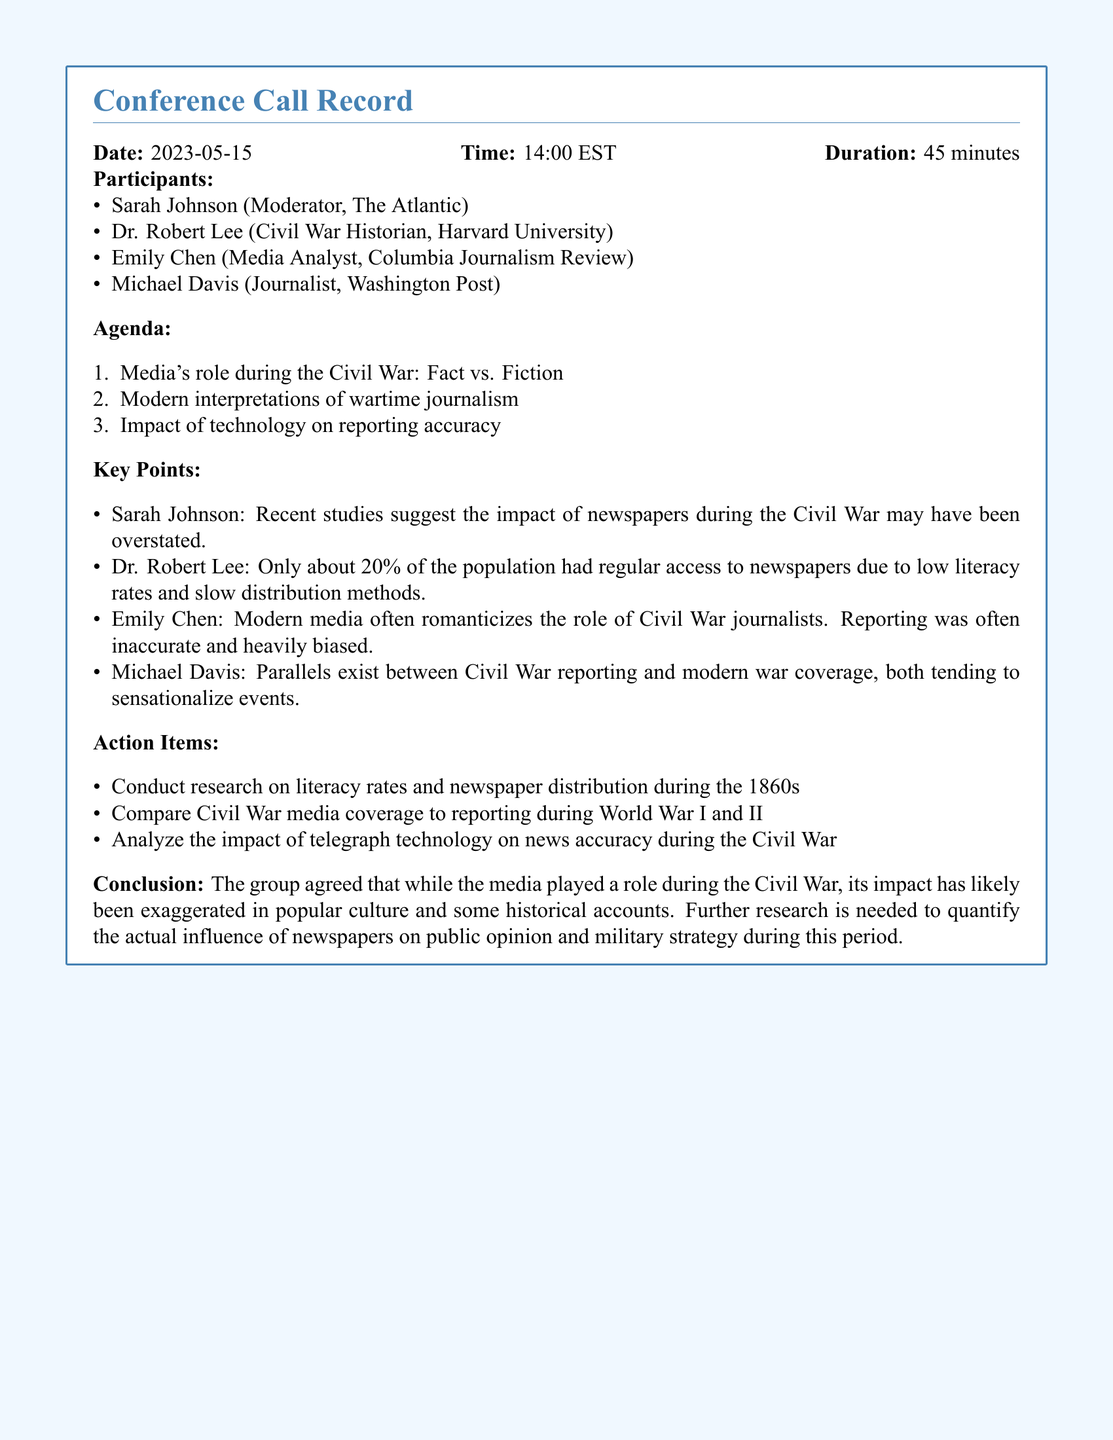what is the date of the conference call? The date of the conference call is stated at the beginning of the document.
Answer: 2023-05-15 who moderated the conference call? The document lists Sarah Johnson as the moderator of the conference call.
Answer: Sarah Johnson how long did the conference call last? The duration of the conference call is mentioned in the document.
Answer: 45 minutes what percentage of the population had regular access to newspapers during the Civil War? Dr. Robert Lee mentioned a specific percentage regarding newspaper access.
Answer: 20% which media organization's representative is named Michael Davis? The document specifies the media organization associated with Michael Davis.
Answer: Washington Post what was one of the key agenda items discussed? The document lists agenda items, including the media's role during the Civil War.
Answer: Media's role during the Civil War: Fact vs. Fiction what did the group conclude about media impact during the Civil War? The conclusion summarizes the consensus of the group regarding media's role.
Answer: Exaggerated in popular culture name one action item from the conference call. The document outlines specific action items agreed upon during the call.
Answer: Conduct research on literacy rates and newspaper distribution during the 1860s which participant is a Civil War historian? One of the participants is mentioned as a Civil War historian in the document.
Answer: Dr. Robert Lee 